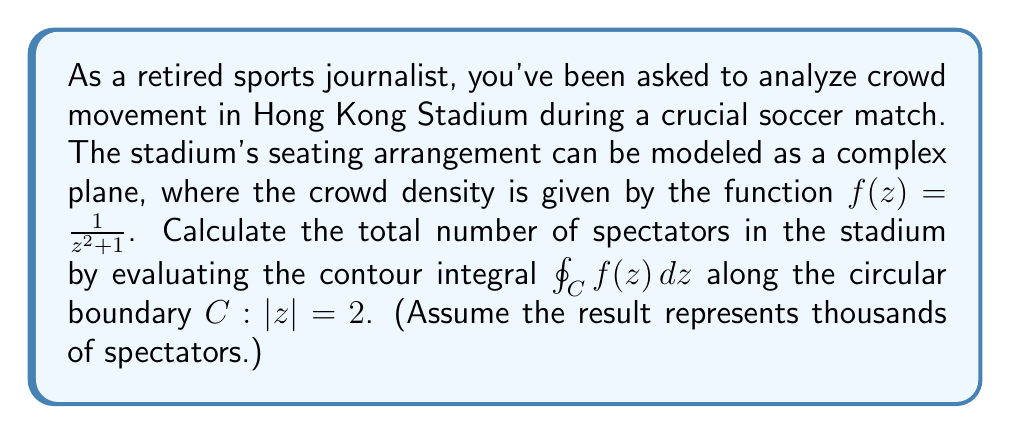What is the answer to this math problem? Let's approach this step-by-step:

1) We're dealing with a contour integral of $f(z) = \frac{1}{z^2 + 1}$ along the circle $|z| = 2$.

2) First, we need to check if there are any singularities inside the contour. The singularities of $f(z)$ occur when $z^2 + 1 = 0$, i.e., at $z = \pm i$.

3) Since $|i| = 1 < 2$, both singularities lie inside our contour.

4) We can use the Residue Theorem: 
   $$\oint_C f(z) dz = 2\pi i \sum \text{Res}(f, a_k)$$
   where $a_k$ are the singularities inside C.

5) To find the residues, we use:
   $$\text{Res}(f, a) = \lim_{z \to a} (z-a)f(z)$$

6) For $a = i$:
   $$\text{Res}(f, i) = \lim_{z \to i} \frac{z-i}{z^2+1} = \lim_{z \to i} \frac{1}{z+i} = \frac{1}{2i}$$

7) For $a = -i$:
   $$\text{Res}(f, -i) = \lim_{z \to -i} \frac{z+i}{z^2+1} = \lim_{z \to -i} \frac{1}{z-i} = -\frac{1}{2i}$$

8) Sum of residues:
   $$\sum \text{Res}(f, a_k) = \frac{1}{2i} - \frac{1}{2i} = 0$$

9) Therefore:
   $$\oint_C f(z) dz = 2\pi i \cdot 0 = 0$$

This result indicates that the net crowd movement along the stadium boundary is zero, which makes sense in a closed stadium where people enter and exit in equal numbers.
Answer: The contour integral evaluates to 0, indicating that the net crowd movement along the stadium boundary is zero. In the context of the question, this suggests that the total number of spectators in the stadium remains constant during the match, with equal numbers entering and exiting. 